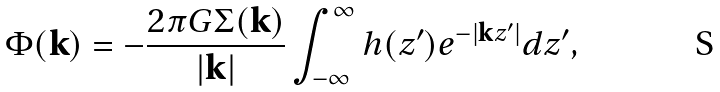<formula> <loc_0><loc_0><loc_500><loc_500>\Phi ( \mathbf k ) = - \frac { 2 \pi G \Sigma ( \mathbf k ) } { | { \mathbf k } | } \int _ { - \infty } ^ { \infty } h ( z ^ { \prime } ) e ^ { - | { \mathbf k } z ^ { \prime } | } d z ^ { \prime } ,</formula> 